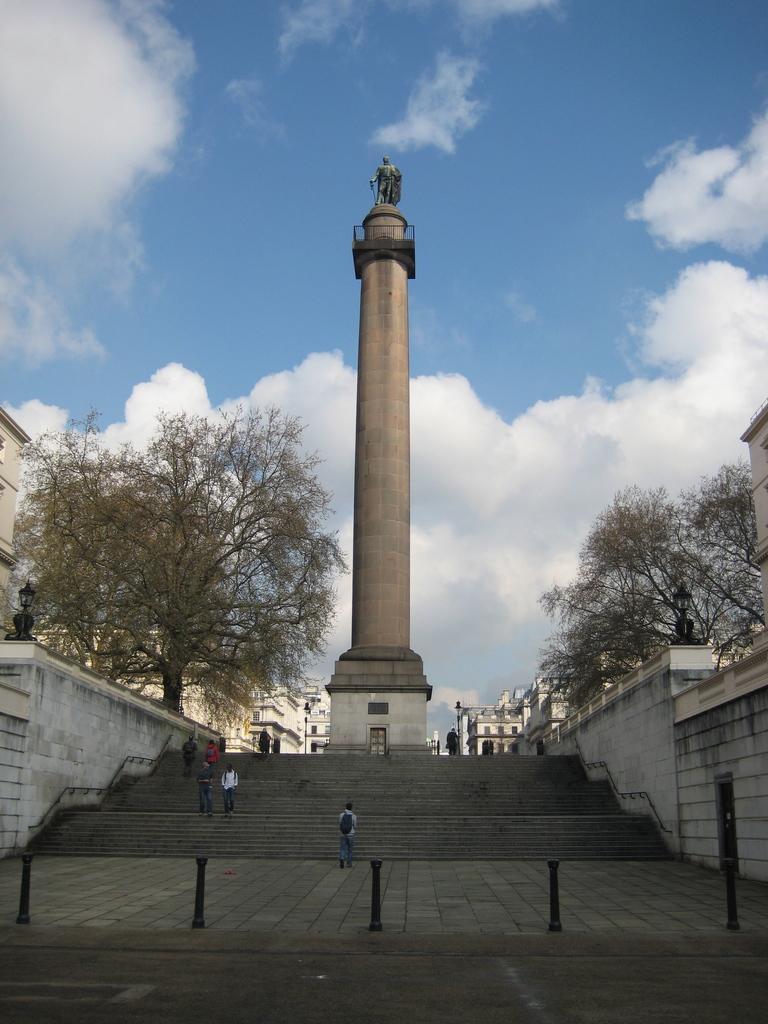Could you give a brief overview of what you see in this image? In this image there is the sky towards the top of the image, there are clouds in the sky, there is a tree towards the right of the image, there is a tree towards the left of the image, there is a sculptor, there are staircase, there are groups of persons walking, there is a man wearing a bag, there are metal objects on the ground, there is wall towards the right of the image, there is a door towards the right of the image, there is a light towards the left of the image, there is road towards the bottom of the image. 